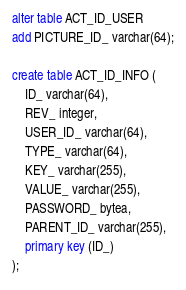Convert code to text. <code><loc_0><loc_0><loc_500><loc_500><_SQL_>alter table ACT_ID_USER 
add PICTURE_ID_ varchar(64);

create table ACT_ID_INFO (
    ID_ varchar(64),
    REV_ integer,
    USER_ID_ varchar(64),
    TYPE_ varchar(64),
    KEY_ varchar(255),
    VALUE_ varchar(255),
    PASSWORD_ bytea,
    PARENT_ID_ varchar(255),
    primary key (ID_)
);
</code> 